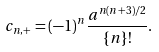Convert formula to latex. <formula><loc_0><loc_0><loc_500><loc_500>c _ { n , + } = ( - 1 ) ^ { n } \frac { a ^ { n ( n + 3 ) / 2 } } { \{ n \} ! } .</formula> 